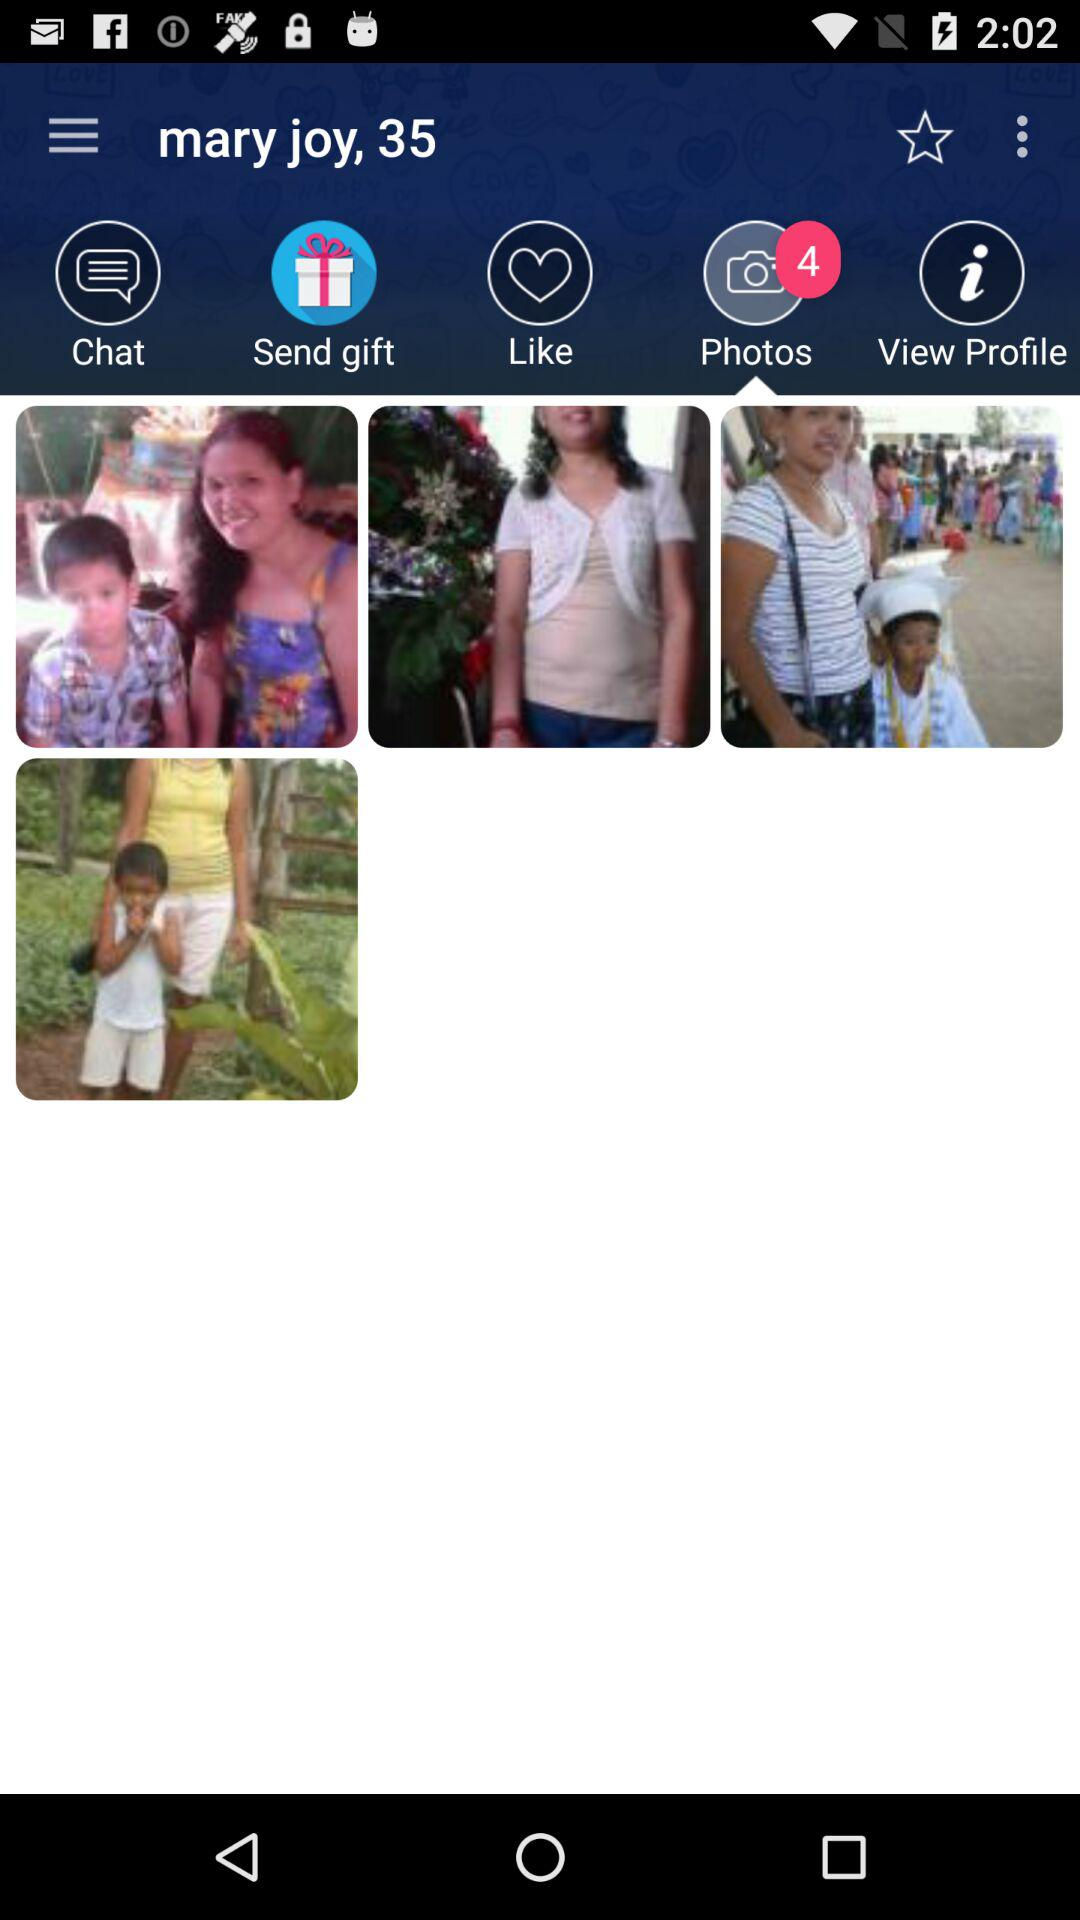What is the mentioned name? The mentioned name is Mary Joy. 